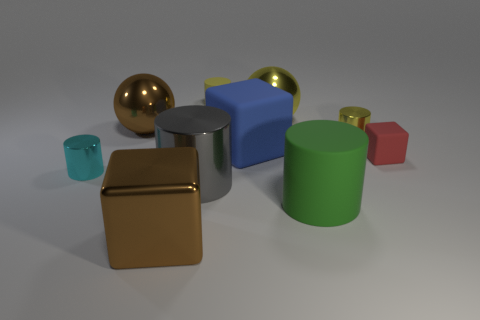Subtract all small matte blocks. How many blocks are left? 2 Subtract all brown balls. How many gray cylinders are left? 1 Subtract all yellow cylinders. How many cylinders are left? 3 Subtract 0 yellow blocks. How many objects are left? 10 Subtract all balls. How many objects are left? 8 Subtract 4 cylinders. How many cylinders are left? 1 Subtract all green balls. Subtract all purple blocks. How many balls are left? 2 Subtract all large gray balls. Subtract all small cyan cylinders. How many objects are left? 9 Add 3 blue rubber blocks. How many blue rubber blocks are left? 4 Add 1 large gray matte cylinders. How many large gray matte cylinders exist? 1 